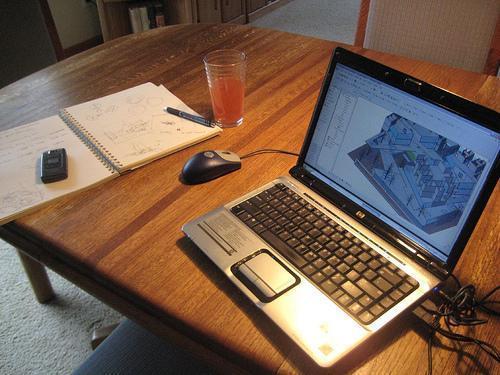How many cups on the table?
Give a very brief answer. 1. 